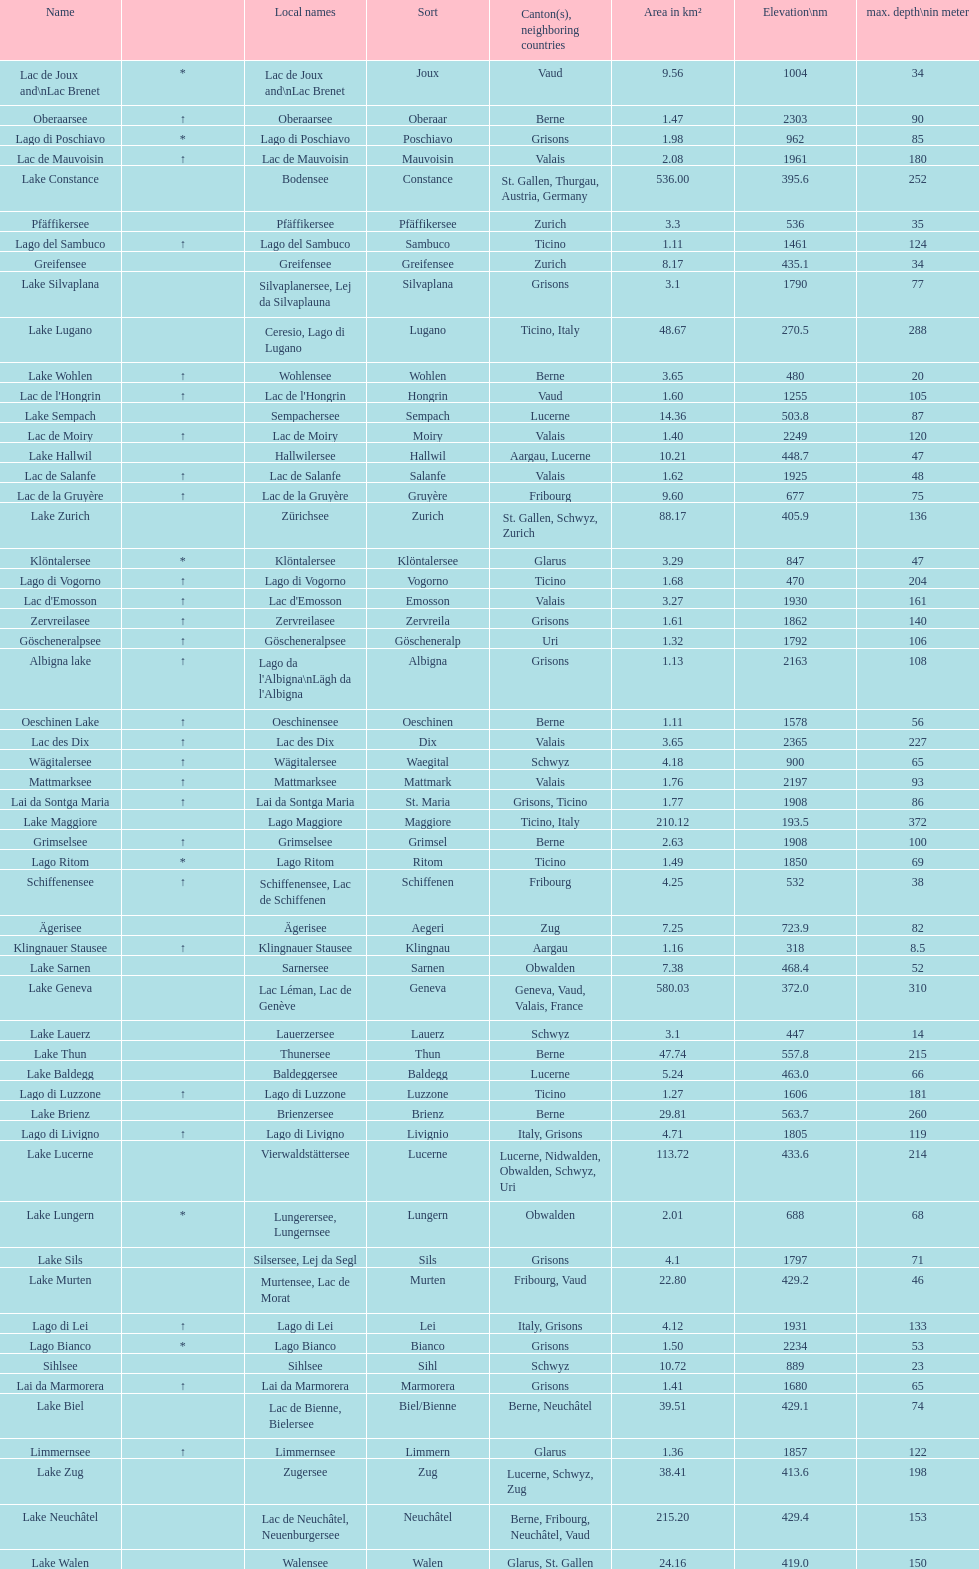Which is the only lake with a max depth of 372m? Lake Maggiore. 